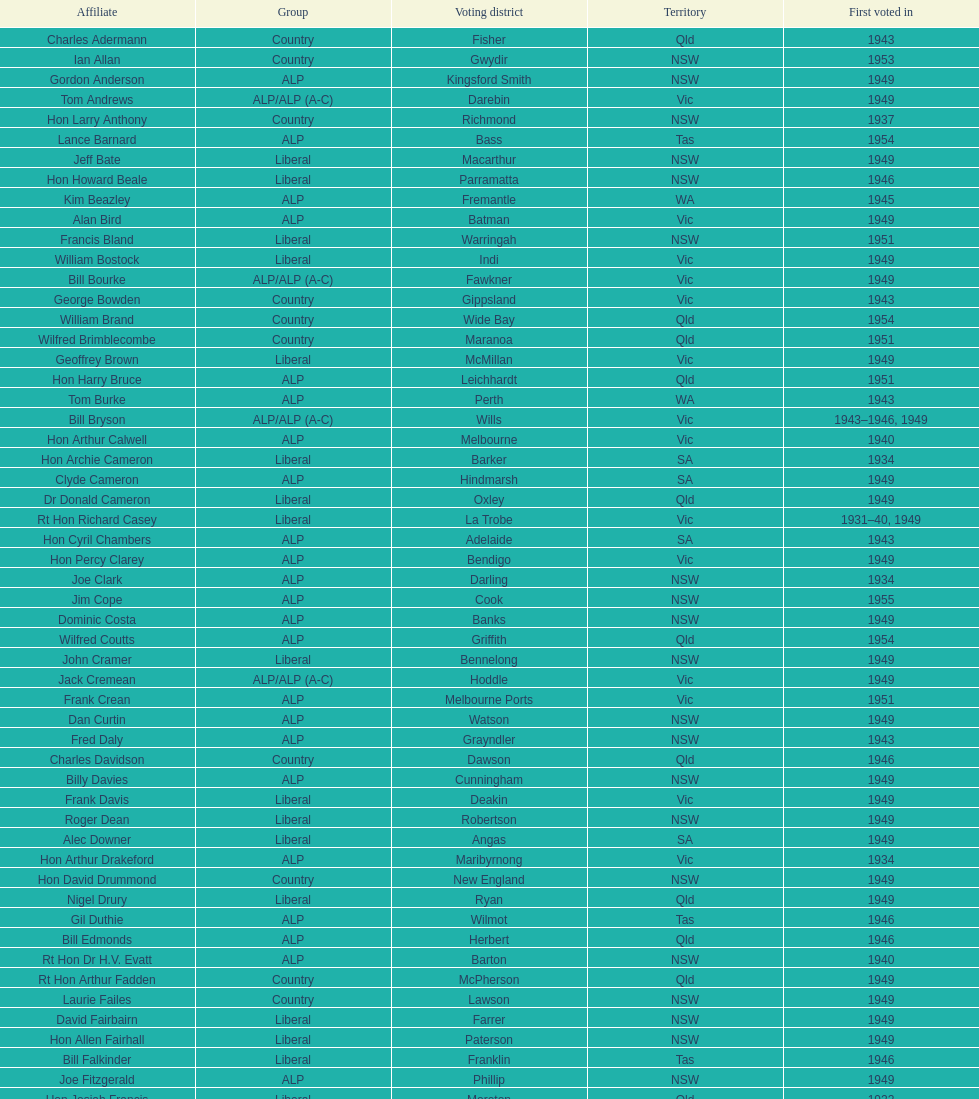When was joe clark first elected? 1934. 